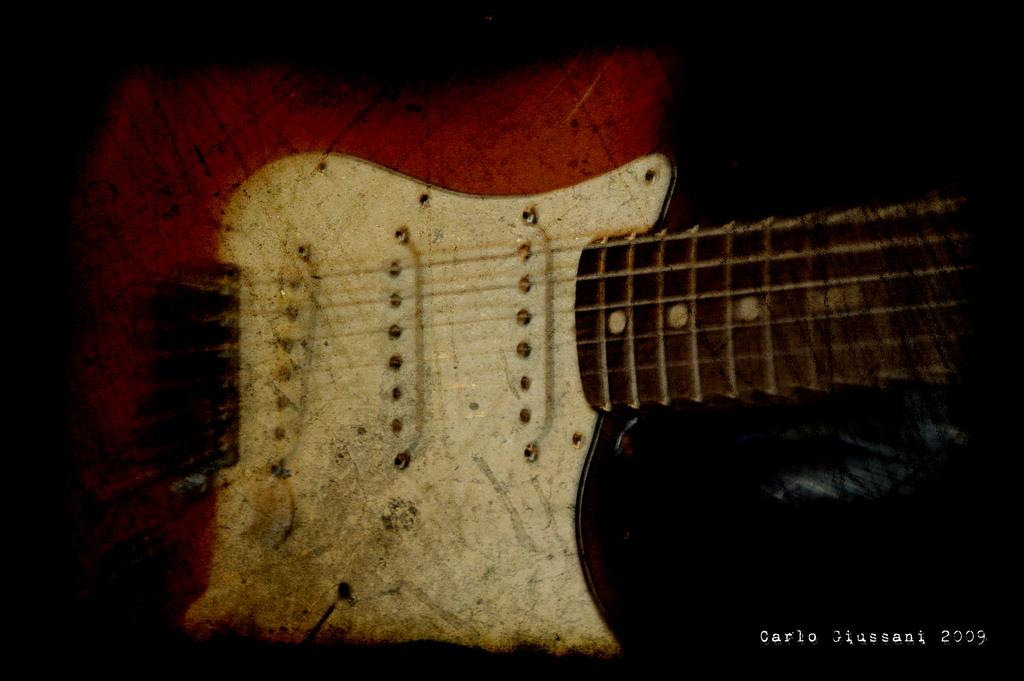What musical instrument is present in the image? There is a guitar in the image. Can you hear the bat laughing and running in the image? There is no bat, laughter, or running depicted in the image; it only features a guitar. 